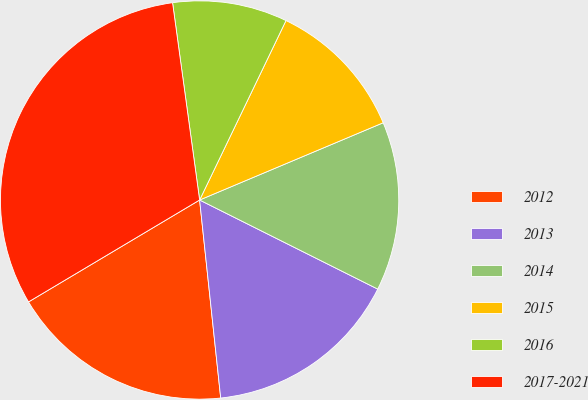Convert chart. <chart><loc_0><loc_0><loc_500><loc_500><pie_chart><fcel>2012<fcel>2013<fcel>2014<fcel>2015<fcel>2016<fcel>2017-2021<nl><fcel>18.14%<fcel>15.93%<fcel>13.72%<fcel>11.52%<fcel>9.31%<fcel>31.38%<nl></chart> 